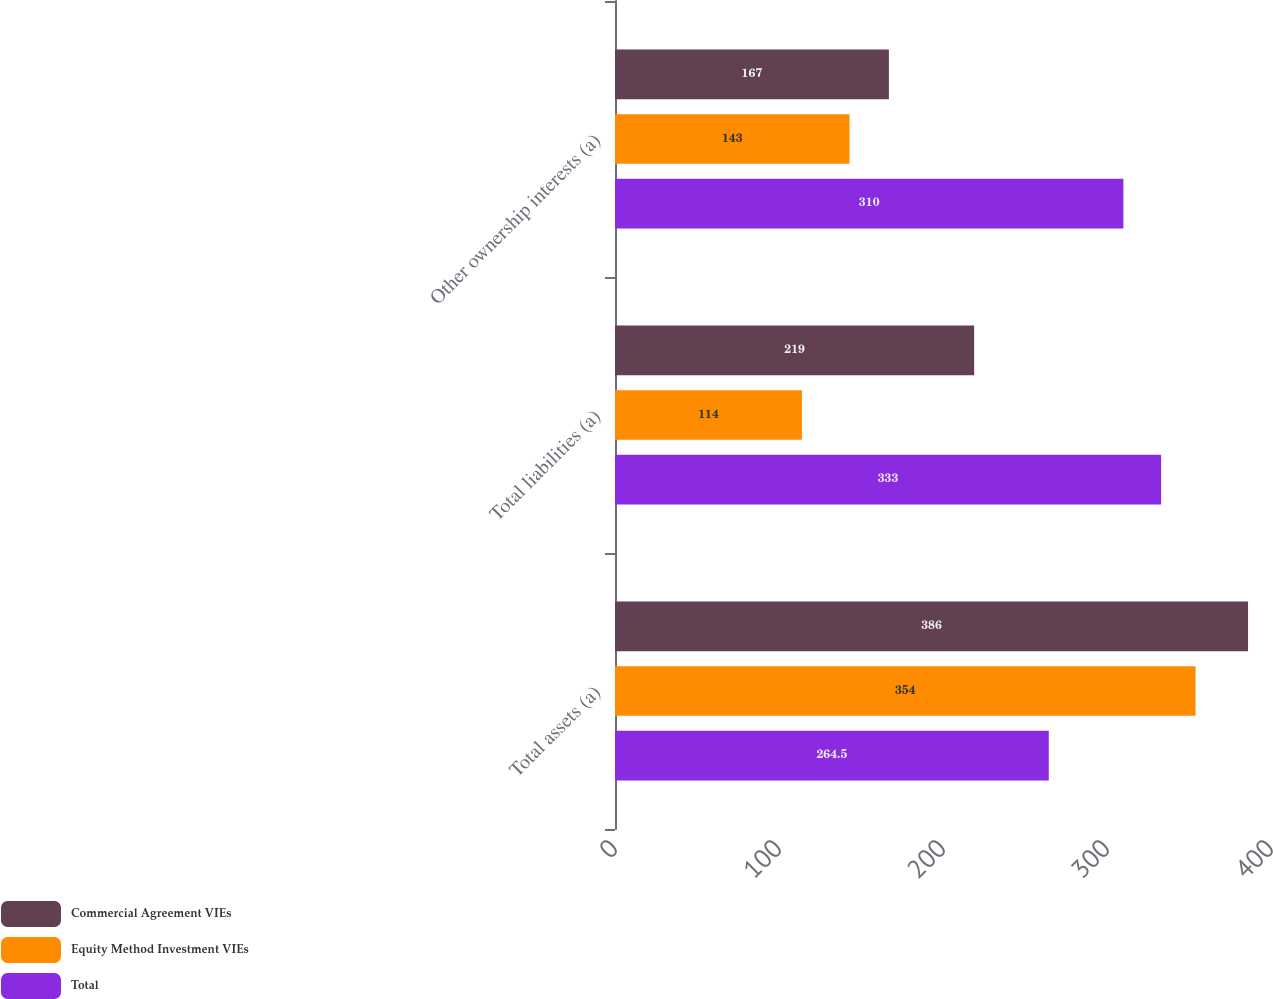Convert chart. <chart><loc_0><loc_0><loc_500><loc_500><stacked_bar_chart><ecel><fcel>Total assets (a)<fcel>Total liabilities (a)<fcel>Other ownership interests (a)<nl><fcel>Commercial Agreement VIEs<fcel>386<fcel>219<fcel>167<nl><fcel>Equity Method Investment VIEs<fcel>354<fcel>114<fcel>143<nl><fcel>Total<fcel>264.5<fcel>333<fcel>310<nl></chart> 